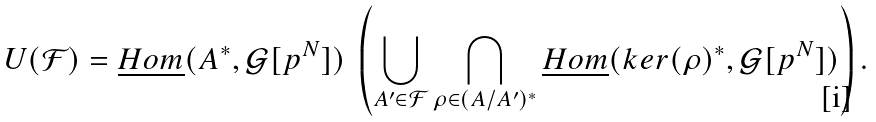<formula> <loc_0><loc_0><loc_500><loc_500>U ( { \mathcal { F } } ) = \underline { H o m } ( A ^ { * } , { \mathcal { G } } [ p ^ { N } ] ) \ \left ( \bigcup _ { A ^ { \prime } \in { \mathcal { F } } } \bigcap _ { \rho \in ( A / A ^ { \prime } ) ^ { * } } \underline { H o m } ( k e r ( \rho ) ^ { * } , { \mathcal { G } } [ p ^ { N } ] ) \right ) .</formula> 